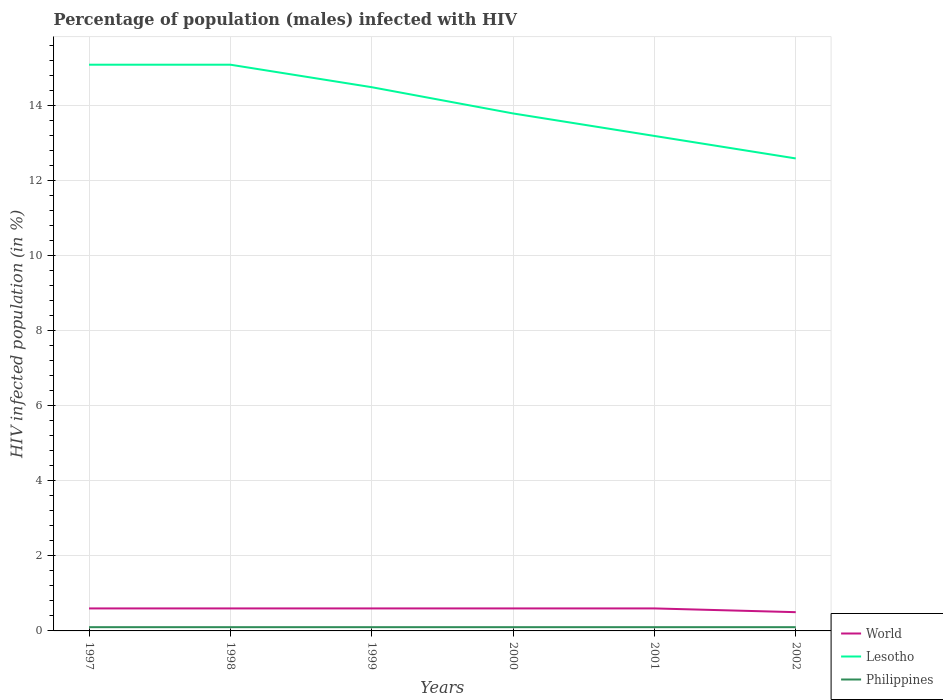How many different coloured lines are there?
Ensure brevity in your answer.  3. Does the line corresponding to Philippines intersect with the line corresponding to Lesotho?
Make the answer very short. No. Is the number of lines equal to the number of legend labels?
Ensure brevity in your answer.  Yes. Across all years, what is the maximum percentage of HIV infected male population in Lesotho?
Your response must be concise. 12.6. What is the total percentage of HIV infected male population in Lesotho in the graph?
Make the answer very short. 1.9. What is the difference between the highest and the lowest percentage of HIV infected male population in Philippines?
Your answer should be compact. 6. How many lines are there?
Your answer should be very brief. 3. What is the difference between two consecutive major ticks on the Y-axis?
Your answer should be compact. 2. Does the graph contain any zero values?
Offer a terse response. No. What is the title of the graph?
Make the answer very short. Percentage of population (males) infected with HIV. What is the label or title of the Y-axis?
Offer a very short reply. HIV infected population (in %). What is the HIV infected population (in %) of World in 1997?
Offer a very short reply. 0.6. What is the HIV infected population (in %) of Lesotho in 1997?
Provide a short and direct response. 15.1. What is the HIV infected population (in %) of Philippines in 1997?
Give a very brief answer. 0.1. What is the HIV infected population (in %) in World in 1998?
Ensure brevity in your answer.  0.6. What is the HIV infected population (in %) in Philippines in 1998?
Offer a very short reply. 0.1. What is the HIV infected population (in %) in World in 1999?
Your answer should be compact. 0.6. What is the HIV infected population (in %) of Lesotho in 1999?
Keep it short and to the point. 14.5. What is the HIV infected population (in %) in Philippines in 1999?
Offer a very short reply. 0.1. What is the HIV infected population (in %) of Lesotho in 2000?
Offer a terse response. 13.8. What is the HIV infected population (in %) in Philippines in 2000?
Offer a terse response. 0.1. What is the HIV infected population (in %) of World in 2001?
Provide a succinct answer. 0.6. What is the HIV infected population (in %) in Lesotho in 2001?
Provide a succinct answer. 13.2. What is the HIV infected population (in %) of Philippines in 2001?
Make the answer very short. 0.1. What is the HIV infected population (in %) of World in 2002?
Your answer should be compact. 0.5. What is the HIV infected population (in %) in Lesotho in 2002?
Your answer should be very brief. 12.6. What is the HIV infected population (in %) in Philippines in 2002?
Keep it short and to the point. 0.1. Across all years, what is the maximum HIV infected population (in %) of Lesotho?
Your answer should be compact. 15.1. Across all years, what is the maximum HIV infected population (in %) in Philippines?
Provide a short and direct response. 0.1. What is the total HIV infected population (in %) in Lesotho in the graph?
Offer a very short reply. 84.3. What is the total HIV infected population (in %) of Philippines in the graph?
Your response must be concise. 0.6. What is the difference between the HIV infected population (in %) in Lesotho in 1997 and that in 1998?
Offer a terse response. 0. What is the difference between the HIV infected population (in %) in Lesotho in 1997 and that in 1999?
Give a very brief answer. 0.6. What is the difference between the HIV infected population (in %) in World in 1997 and that in 2000?
Your response must be concise. 0. What is the difference between the HIV infected population (in %) of Lesotho in 1997 and that in 2000?
Provide a succinct answer. 1.3. What is the difference between the HIV infected population (in %) of Philippines in 1997 and that in 2000?
Keep it short and to the point. 0. What is the difference between the HIV infected population (in %) of World in 1997 and that in 2001?
Your response must be concise. 0. What is the difference between the HIV infected population (in %) of Lesotho in 1997 and that in 2001?
Provide a succinct answer. 1.9. What is the difference between the HIV infected population (in %) in Philippines in 1997 and that in 2001?
Give a very brief answer. 0. What is the difference between the HIV infected population (in %) of Philippines in 1998 and that in 1999?
Keep it short and to the point. 0. What is the difference between the HIV infected population (in %) in Lesotho in 1998 and that in 2000?
Keep it short and to the point. 1.3. What is the difference between the HIV infected population (in %) of Lesotho in 1998 and that in 2001?
Offer a terse response. 1.9. What is the difference between the HIV infected population (in %) of World in 1998 and that in 2002?
Your response must be concise. 0.1. What is the difference between the HIV infected population (in %) of Lesotho in 1998 and that in 2002?
Offer a terse response. 2.5. What is the difference between the HIV infected population (in %) of Lesotho in 1999 and that in 2001?
Your answer should be compact. 1.3. What is the difference between the HIV infected population (in %) in Philippines in 1999 and that in 2001?
Give a very brief answer. 0. What is the difference between the HIV infected population (in %) of World in 1999 and that in 2002?
Your answer should be very brief. 0.1. What is the difference between the HIV infected population (in %) of Philippines in 1999 and that in 2002?
Your answer should be compact. 0. What is the difference between the HIV infected population (in %) of World in 2000 and that in 2001?
Ensure brevity in your answer.  0. What is the difference between the HIV infected population (in %) in Lesotho in 2000 and that in 2001?
Provide a short and direct response. 0.6. What is the difference between the HIV infected population (in %) in Philippines in 2000 and that in 2001?
Make the answer very short. 0. What is the difference between the HIV infected population (in %) in World in 2000 and that in 2002?
Offer a terse response. 0.1. What is the difference between the HIV infected population (in %) of World in 1997 and the HIV infected population (in %) of Philippines in 1998?
Offer a very short reply. 0.5. What is the difference between the HIV infected population (in %) of World in 1997 and the HIV infected population (in %) of Lesotho in 1999?
Offer a very short reply. -13.9. What is the difference between the HIV infected population (in %) in Lesotho in 1997 and the HIV infected population (in %) in Philippines in 1999?
Ensure brevity in your answer.  15. What is the difference between the HIV infected population (in %) of World in 1997 and the HIV infected population (in %) of Philippines in 2000?
Your answer should be compact. 0.5. What is the difference between the HIV infected population (in %) of Lesotho in 1997 and the HIV infected population (in %) of Philippines in 2000?
Make the answer very short. 15. What is the difference between the HIV infected population (in %) in World in 1997 and the HIV infected population (in %) in Philippines in 2001?
Keep it short and to the point. 0.5. What is the difference between the HIV infected population (in %) of World in 1997 and the HIV infected population (in %) of Lesotho in 2002?
Your answer should be very brief. -12. What is the difference between the HIV infected population (in %) of Lesotho in 1997 and the HIV infected population (in %) of Philippines in 2002?
Offer a very short reply. 15. What is the difference between the HIV infected population (in %) of World in 1998 and the HIV infected population (in %) of Lesotho in 1999?
Ensure brevity in your answer.  -13.9. What is the difference between the HIV infected population (in %) in Lesotho in 1998 and the HIV infected population (in %) in Philippines in 1999?
Offer a very short reply. 15. What is the difference between the HIV infected population (in %) of Lesotho in 1998 and the HIV infected population (in %) of Philippines in 2001?
Your answer should be very brief. 15. What is the difference between the HIV infected population (in %) of World in 1998 and the HIV infected population (in %) of Lesotho in 2002?
Provide a short and direct response. -12. What is the difference between the HIV infected population (in %) of World in 1998 and the HIV infected population (in %) of Philippines in 2002?
Keep it short and to the point. 0.5. What is the difference between the HIV infected population (in %) of Lesotho in 1998 and the HIV infected population (in %) of Philippines in 2002?
Offer a terse response. 15. What is the difference between the HIV infected population (in %) in World in 1999 and the HIV infected population (in %) in Philippines in 2000?
Give a very brief answer. 0.5. What is the difference between the HIV infected population (in %) of World in 1999 and the HIV infected population (in %) of Lesotho in 2001?
Your answer should be compact. -12.6. What is the difference between the HIV infected population (in %) of World in 1999 and the HIV infected population (in %) of Philippines in 2001?
Your answer should be compact. 0.5. What is the difference between the HIV infected population (in %) of World in 1999 and the HIV infected population (in %) of Philippines in 2002?
Your answer should be very brief. 0.5. What is the difference between the HIV infected population (in %) of World in 2000 and the HIV infected population (in %) of Lesotho in 2001?
Ensure brevity in your answer.  -12.6. What is the difference between the HIV infected population (in %) of Lesotho in 2000 and the HIV infected population (in %) of Philippines in 2001?
Your answer should be compact. 13.7. What is the average HIV infected population (in %) of World per year?
Your answer should be compact. 0.58. What is the average HIV infected population (in %) in Lesotho per year?
Make the answer very short. 14.05. In the year 1998, what is the difference between the HIV infected population (in %) in World and HIV infected population (in %) in Lesotho?
Provide a succinct answer. -14.5. In the year 1998, what is the difference between the HIV infected population (in %) in World and HIV infected population (in %) in Philippines?
Your response must be concise. 0.5. In the year 1998, what is the difference between the HIV infected population (in %) in Lesotho and HIV infected population (in %) in Philippines?
Make the answer very short. 15. In the year 1999, what is the difference between the HIV infected population (in %) in World and HIV infected population (in %) in Lesotho?
Give a very brief answer. -13.9. In the year 1999, what is the difference between the HIV infected population (in %) in World and HIV infected population (in %) in Philippines?
Offer a very short reply. 0.5. In the year 2000, what is the difference between the HIV infected population (in %) of World and HIV infected population (in %) of Philippines?
Provide a short and direct response. 0.5. In the year 2000, what is the difference between the HIV infected population (in %) in Lesotho and HIV infected population (in %) in Philippines?
Your response must be concise. 13.7. In the year 2001, what is the difference between the HIV infected population (in %) in World and HIV infected population (in %) in Lesotho?
Ensure brevity in your answer.  -12.6. In the year 2002, what is the difference between the HIV infected population (in %) in Lesotho and HIV infected population (in %) in Philippines?
Offer a terse response. 12.5. What is the ratio of the HIV infected population (in %) in World in 1997 to that in 1998?
Your answer should be very brief. 1. What is the ratio of the HIV infected population (in %) of Lesotho in 1997 to that in 1999?
Provide a short and direct response. 1.04. What is the ratio of the HIV infected population (in %) in World in 1997 to that in 2000?
Ensure brevity in your answer.  1. What is the ratio of the HIV infected population (in %) in Lesotho in 1997 to that in 2000?
Offer a terse response. 1.09. What is the ratio of the HIV infected population (in %) in Lesotho in 1997 to that in 2001?
Give a very brief answer. 1.14. What is the ratio of the HIV infected population (in %) in Philippines in 1997 to that in 2001?
Make the answer very short. 1. What is the ratio of the HIV infected population (in %) in Lesotho in 1997 to that in 2002?
Offer a very short reply. 1.2. What is the ratio of the HIV infected population (in %) in Lesotho in 1998 to that in 1999?
Your answer should be compact. 1.04. What is the ratio of the HIV infected population (in %) of Lesotho in 1998 to that in 2000?
Provide a succinct answer. 1.09. What is the ratio of the HIV infected population (in %) of Lesotho in 1998 to that in 2001?
Your response must be concise. 1.14. What is the ratio of the HIV infected population (in %) in Lesotho in 1998 to that in 2002?
Ensure brevity in your answer.  1.2. What is the ratio of the HIV infected population (in %) of Philippines in 1998 to that in 2002?
Make the answer very short. 1. What is the ratio of the HIV infected population (in %) of World in 1999 to that in 2000?
Offer a terse response. 1. What is the ratio of the HIV infected population (in %) in Lesotho in 1999 to that in 2000?
Your answer should be very brief. 1.05. What is the ratio of the HIV infected population (in %) in Lesotho in 1999 to that in 2001?
Your answer should be compact. 1.1. What is the ratio of the HIV infected population (in %) of Philippines in 1999 to that in 2001?
Keep it short and to the point. 1. What is the ratio of the HIV infected population (in %) in Lesotho in 1999 to that in 2002?
Your response must be concise. 1.15. What is the ratio of the HIV infected population (in %) of World in 2000 to that in 2001?
Your response must be concise. 1. What is the ratio of the HIV infected population (in %) in Lesotho in 2000 to that in 2001?
Your answer should be very brief. 1.05. What is the ratio of the HIV infected population (in %) of World in 2000 to that in 2002?
Your response must be concise. 1.2. What is the ratio of the HIV infected population (in %) of Lesotho in 2000 to that in 2002?
Your answer should be very brief. 1.1. What is the ratio of the HIV infected population (in %) in Lesotho in 2001 to that in 2002?
Provide a short and direct response. 1.05. What is the difference between the highest and the second highest HIV infected population (in %) of World?
Your answer should be very brief. 0. What is the difference between the highest and the second highest HIV infected population (in %) in Lesotho?
Your answer should be compact. 0. What is the difference between the highest and the second highest HIV infected population (in %) of Philippines?
Your response must be concise. 0. 